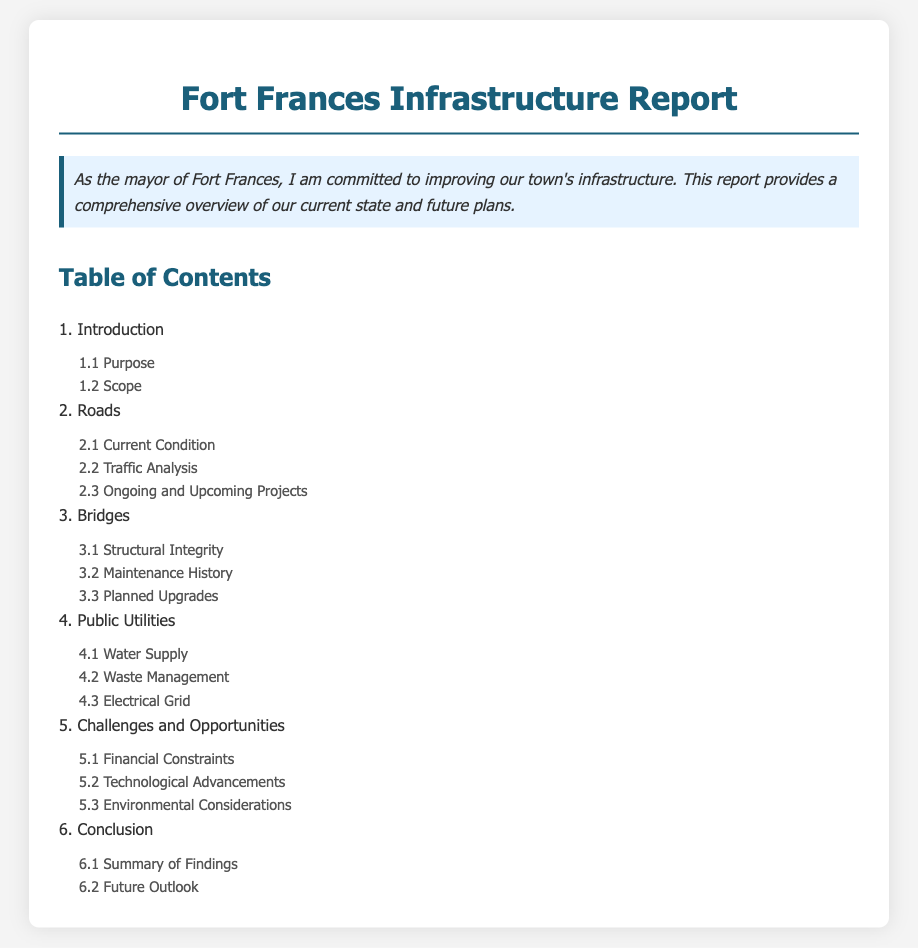What is the purpose of the report? The purpose is likely detailed in section 1.1 of the document.
Answer: Purpose What section discusses the current condition of roads? The current condition of roads is discussed in section 2.1.
Answer: 2.1 Current Condition What is the title of section 4? Section 4 is focused on public utilities, indicating the topics within that section.
Answer: Public Utilities Which aspect of bridges is addressed in section 3.1? Section 3.1 tackles the structural integrity of bridges.
Answer: Structural Integrity How many subitems are under the 'Challenges and Opportunities' section? The number of subitems can be found by counting the entries under section 5.
Answer: 3 What aspect of the electric supply can be found in section 4.3? Section 4.3 specifically addresses the electrical grid.
Answer: Electrical Grid What is the final section of the document? The final section is titled Conclusion, summarizing the findings and future outlook.
Answer: Conclusion What does section 5.2 focus on? Section 5.2 discusses the advances in technology that could impact infrastructure.
Answer: Technological Advancements What is the subitem that discusses maintenance history of bridges? The maintenance history of bridges is covered in section 3.2.
Answer: 3.2 Maintenance History 